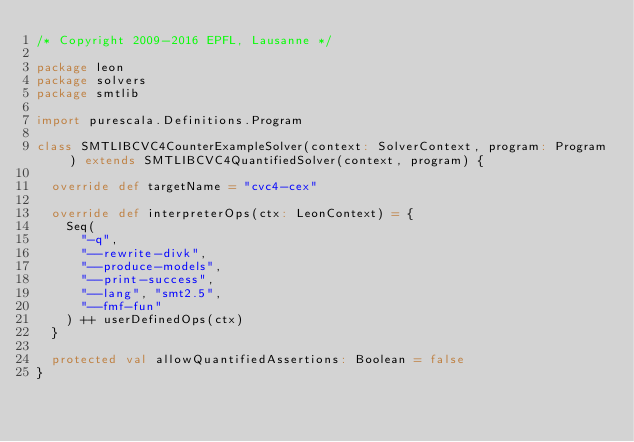<code> <loc_0><loc_0><loc_500><loc_500><_Scala_>/* Copyright 2009-2016 EPFL, Lausanne */

package leon
package solvers
package smtlib

import purescala.Definitions.Program

class SMTLIBCVC4CounterExampleSolver(context: SolverContext, program: Program) extends SMTLIBCVC4QuantifiedSolver(context, program) {

  override def targetName = "cvc4-cex"

  override def interpreterOps(ctx: LeonContext) = {
    Seq(
      "-q",
      "--rewrite-divk",
      "--produce-models",
      "--print-success",
      "--lang", "smt2.5",
      "--fmf-fun"
    ) ++ userDefinedOps(ctx)
  }

  protected val allowQuantifiedAssertions: Boolean = false
}
</code> 